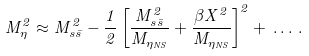Convert formula to latex. <formula><loc_0><loc_0><loc_500><loc_500>M _ { \eta } ^ { 2 } \approx M _ { s \bar { s } } ^ { 2 } - \frac { 1 } { 2 } \left [ \frac { M _ { s \bar { s } } ^ { 2 } } { M _ { \eta _ { N S } } } + \frac { \beta X ^ { 2 } } { M _ { \eta _ { N S } } } \right ] ^ { 2 } + \, \dots \, .</formula> 